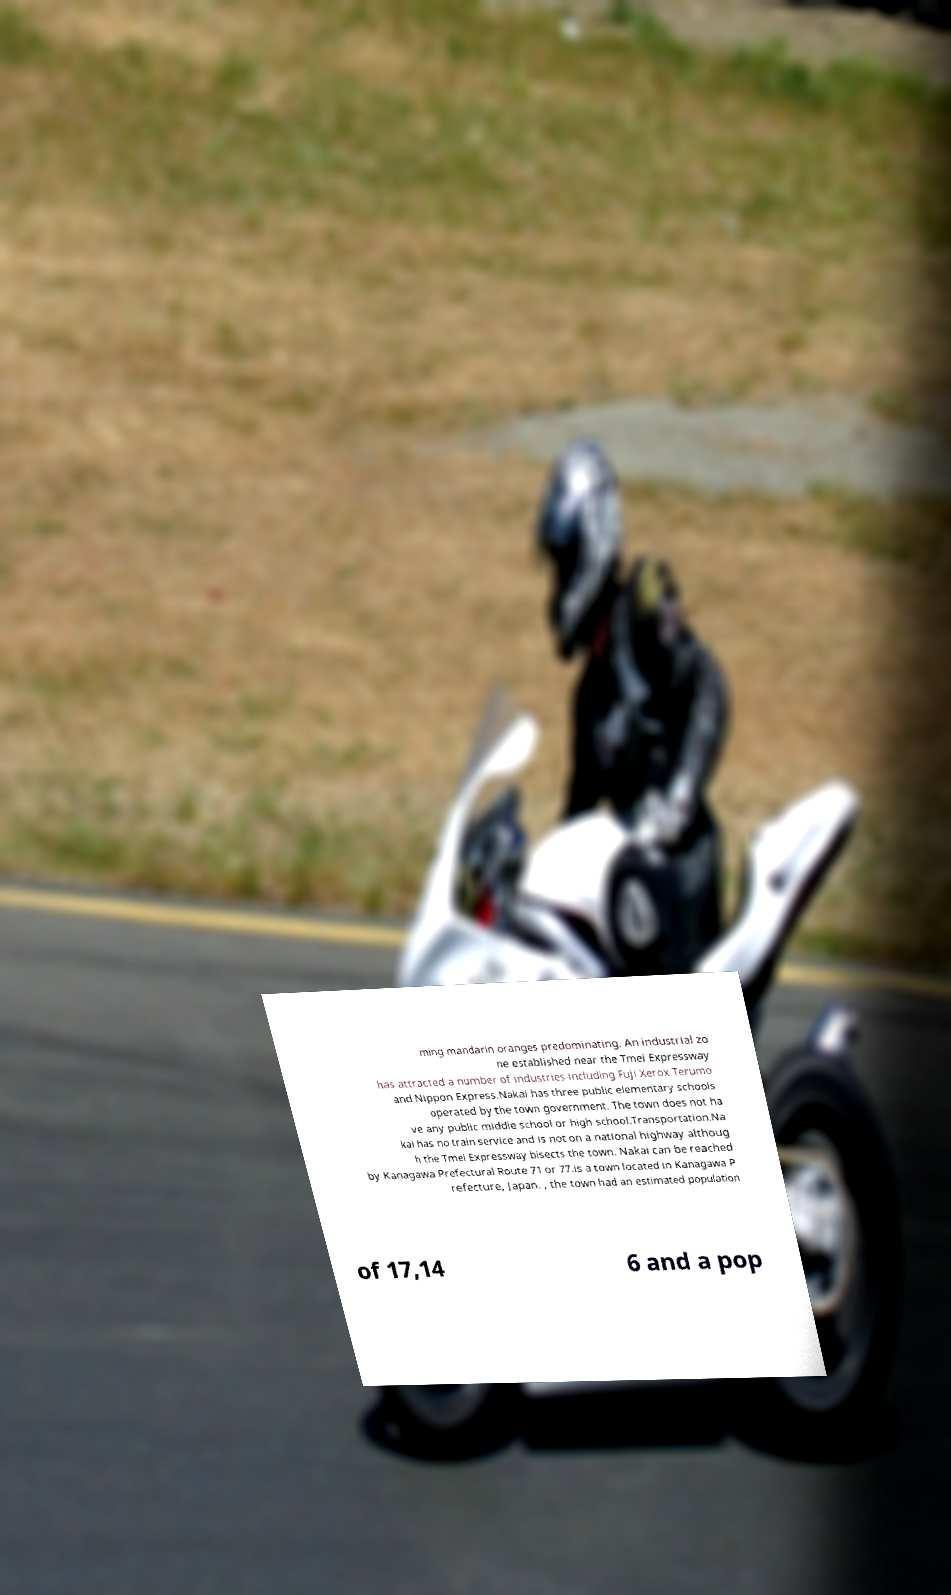I need the written content from this picture converted into text. Can you do that? ming mandarin oranges predominating. An industrial zo ne established near the Tmei Expressway has attracted a number of industries including Fuji Xerox Terumo and Nippon Express.Nakai has three public elementary schools operated by the town government. The town does not ha ve any public middle school or high school.Transportation.Na kai has no train service and is not on a national highway althoug h the Tmei Expressway bisects the town. Nakai can be reached by Kanagawa Prefectural Route 71 or 77.is a town located in Kanagawa P refecture, Japan. , the town had an estimated population of 17,14 6 and a pop 